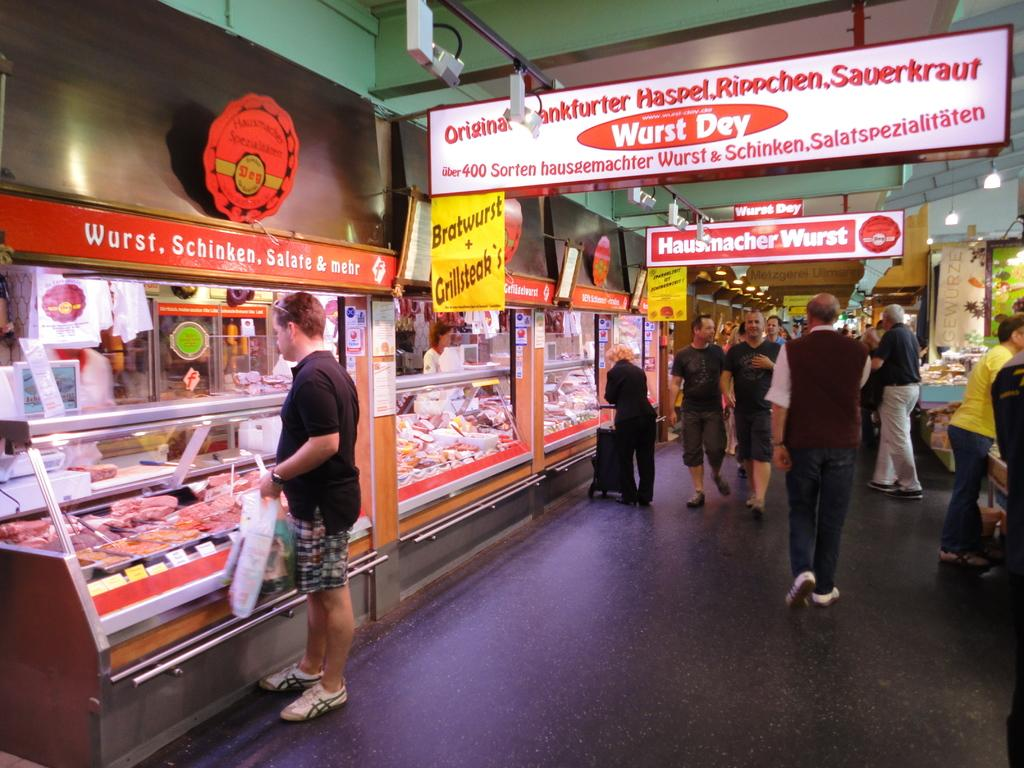<image>
Relay a brief, clear account of the picture shown. A bunch of people walking around under signs that say Wurst Dey. 